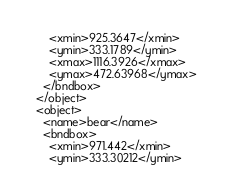<code> <loc_0><loc_0><loc_500><loc_500><_XML_>      <xmin>925.3647</xmin>
      <ymin>333.1789</ymin>
      <xmax>1116.3926</xmax>
      <ymax>472.63968</ymax>
    </bndbox>
  </object>
  <object>
    <name>bear</name>
    <bndbox>
      <xmin>971.442</xmin>
      <ymin>333.30212</ymin></code> 